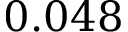Convert formula to latex. <formula><loc_0><loc_0><loc_500><loc_500>0 . 0 4 8</formula> 